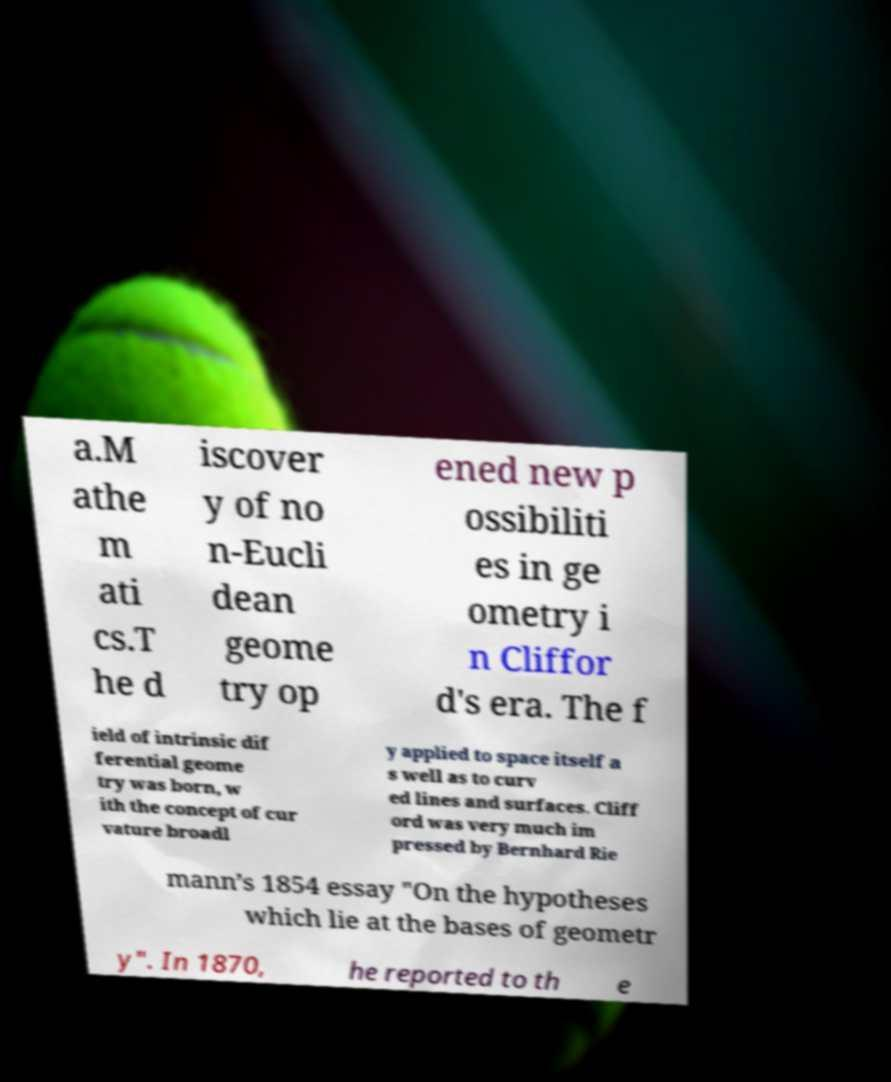Please identify and transcribe the text found in this image. a.M athe m ati cs.T he d iscover y of no n-Eucli dean geome try op ened new p ossibiliti es in ge ometry i n Cliffor d's era. The f ield of intrinsic dif ferential geome try was born, w ith the concept of cur vature broadl y applied to space itself a s well as to curv ed lines and surfaces. Cliff ord was very much im pressed by Bernhard Rie mann’s 1854 essay "On the hypotheses which lie at the bases of geometr y". In 1870, he reported to th e 